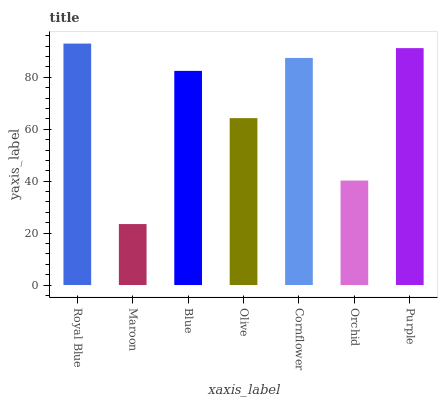Is Maroon the minimum?
Answer yes or no. Yes. Is Royal Blue the maximum?
Answer yes or no. Yes. Is Blue the minimum?
Answer yes or no. No. Is Blue the maximum?
Answer yes or no. No. Is Blue greater than Maroon?
Answer yes or no. Yes. Is Maroon less than Blue?
Answer yes or no. Yes. Is Maroon greater than Blue?
Answer yes or no. No. Is Blue less than Maroon?
Answer yes or no. No. Is Blue the high median?
Answer yes or no. Yes. Is Blue the low median?
Answer yes or no. Yes. Is Orchid the high median?
Answer yes or no. No. Is Olive the low median?
Answer yes or no. No. 